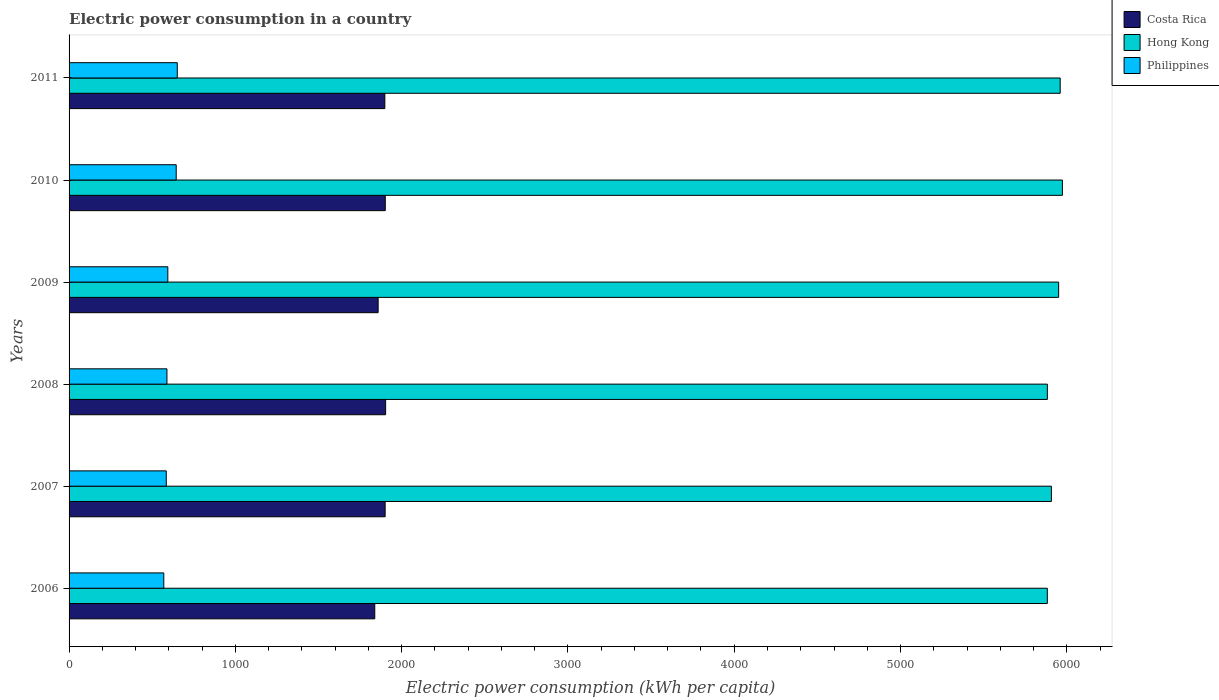How many different coloured bars are there?
Provide a short and direct response. 3. How many groups of bars are there?
Offer a terse response. 6. Are the number of bars on each tick of the Y-axis equal?
Keep it short and to the point. Yes. What is the label of the 6th group of bars from the top?
Offer a very short reply. 2006. What is the electric power consumption in in Hong Kong in 2010?
Make the answer very short. 5973.49. Across all years, what is the maximum electric power consumption in in Philippines?
Make the answer very short. 650.74. Across all years, what is the minimum electric power consumption in in Hong Kong?
Offer a terse response. 5882.81. In which year was the electric power consumption in in Philippines maximum?
Keep it short and to the point. 2011. What is the total electric power consumption in in Hong Kong in the graph?
Offer a terse response. 3.56e+04. What is the difference between the electric power consumption in in Costa Rica in 2008 and that in 2009?
Your answer should be very brief. 44.97. What is the difference between the electric power consumption in in Costa Rica in 2009 and the electric power consumption in in Hong Kong in 2011?
Your response must be concise. -4101.55. What is the average electric power consumption in in Philippines per year?
Offer a very short reply. 605.26. In the year 2006, what is the difference between the electric power consumption in in Philippines and electric power consumption in in Hong Kong?
Provide a succinct answer. -5313.15. In how many years, is the electric power consumption in in Hong Kong greater than 3000 kWh per capita?
Offer a very short reply. 6. What is the ratio of the electric power consumption in in Philippines in 2009 to that in 2010?
Give a very brief answer. 0.92. Is the electric power consumption in in Philippines in 2009 less than that in 2010?
Provide a short and direct response. Yes. What is the difference between the highest and the second highest electric power consumption in in Philippines?
Make the answer very short. 6.47. What is the difference between the highest and the lowest electric power consumption in in Hong Kong?
Ensure brevity in your answer.  90.68. In how many years, is the electric power consumption in in Hong Kong greater than the average electric power consumption in in Hong Kong taken over all years?
Your answer should be compact. 3. Is the sum of the electric power consumption in in Costa Rica in 2007 and 2010 greater than the maximum electric power consumption in in Philippines across all years?
Provide a short and direct response. Yes. What does the 2nd bar from the top in 2010 represents?
Give a very brief answer. Hong Kong. Is it the case that in every year, the sum of the electric power consumption in in Costa Rica and electric power consumption in in Hong Kong is greater than the electric power consumption in in Philippines?
Provide a succinct answer. Yes. How many bars are there?
Provide a short and direct response. 18. What is the difference between two consecutive major ticks on the X-axis?
Ensure brevity in your answer.  1000. Does the graph contain grids?
Your answer should be compact. No. Where does the legend appear in the graph?
Your response must be concise. Top right. How many legend labels are there?
Make the answer very short. 3. How are the legend labels stacked?
Provide a succinct answer. Vertical. What is the title of the graph?
Your answer should be compact. Electric power consumption in a country. What is the label or title of the X-axis?
Make the answer very short. Electric power consumption (kWh per capita). What is the label or title of the Y-axis?
Offer a very short reply. Years. What is the Electric power consumption (kWh per capita) in Costa Rica in 2006?
Your answer should be compact. 1838.34. What is the Electric power consumption (kWh per capita) in Hong Kong in 2006?
Give a very brief answer. 5882.81. What is the Electric power consumption (kWh per capita) of Philippines in 2006?
Keep it short and to the point. 569.66. What is the Electric power consumption (kWh per capita) of Costa Rica in 2007?
Keep it short and to the point. 1900.69. What is the Electric power consumption (kWh per capita) of Hong Kong in 2007?
Offer a very short reply. 5907.35. What is the Electric power consumption (kWh per capita) in Philippines in 2007?
Your answer should be compact. 584.53. What is the Electric power consumption (kWh per capita) of Costa Rica in 2008?
Make the answer very short. 1903.6. What is the Electric power consumption (kWh per capita) in Hong Kong in 2008?
Your response must be concise. 5883.04. What is the Electric power consumption (kWh per capita) in Philippines in 2008?
Give a very brief answer. 588.51. What is the Electric power consumption (kWh per capita) of Costa Rica in 2009?
Ensure brevity in your answer.  1858.63. What is the Electric power consumption (kWh per capita) in Hong Kong in 2009?
Offer a very short reply. 5950.84. What is the Electric power consumption (kWh per capita) in Philippines in 2009?
Your answer should be very brief. 593.86. What is the Electric power consumption (kWh per capita) in Costa Rica in 2010?
Keep it short and to the point. 1901.54. What is the Electric power consumption (kWh per capita) in Hong Kong in 2010?
Keep it short and to the point. 5973.49. What is the Electric power consumption (kWh per capita) in Philippines in 2010?
Give a very brief answer. 644.27. What is the Electric power consumption (kWh per capita) in Costa Rica in 2011?
Make the answer very short. 1898.93. What is the Electric power consumption (kWh per capita) of Hong Kong in 2011?
Provide a succinct answer. 5960.18. What is the Electric power consumption (kWh per capita) of Philippines in 2011?
Offer a terse response. 650.74. Across all years, what is the maximum Electric power consumption (kWh per capita) of Costa Rica?
Your answer should be very brief. 1903.6. Across all years, what is the maximum Electric power consumption (kWh per capita) in Hong Kong?
Provide a short and direct response. 5973.49. Across all years, what is the maximum Electric power consumption (kWh per capita) in Philippines?
Provide a short and direct response. 650.74. Across all years, what is the minimum Electric power consumption (kWh per capita) of Costa Rica?
Your answer should be very brief. 1838.34. Across all years, what is the minimum Electric power consumption (kWh per capita) in Hong Kong?
Offer a terse response. 5882.81. Across all years, what is the minimum Electric power consumption (kWh per capita) of Philippines?
Give a very brief answer. 569.66. What is the total Electric power consumption (kWh per capita) in Costa Rica in the graph?
Provide a short and direct response. 1.13e+04. What is the total Electric power consumption (kWh per capita) in Hong Kong in the graph?
Keep it short and to the point. 3.56e+04. What is the total Electric power consumption (kWh per capita) in Philippines in the graph?
Offer a very short reply. 3631.57. What is the difference between the Electric power consumption (kWh per capita) of Costa Rica in 2006 and that in 2007?
Provide a short and direct response. -62.36. What is the difference between the Electric power consumption (kWh per capita) of Hong Kong in 2006 and that in 2007?
Keep it short and to the point. -24.54. What is the difference between the Electric power consumption (kWh per capita) in Philippines in 2006 and that in 2007?
Provide a succinct answer. -14.87. What is the difference between the Electric power consumption (kWh per capita) in Costa Rica in 2006 and that in 2008?
Offer a very short reply. -65.26. What is the difference between the Electric power consumption (kWh per capita) in Hong Kong in 2006 and that in 2008?
Your answer should be very brief. -0.23. What is the difference between the Electric power consumption (kWh per capita) in Philippines in 2006 and that in 2008?
Offer a terse response. -18.85. What is the difference between the Electric power consumption (kWh per capita) in Costa Rica in 2006 and that in 2009?
Your answer should be very brief. -20.29. What is the difference between the Electric power consumption (kWh per capita) in Hong Kong in 2006 and that in 2009?
Ensure brevity in your answer.  -68.03. What is the difference between the Electric power consumption (kWh per capita) of Philippines in 2006 and that in 2009?
Your response must be concise. -24.2. What is the difference between the Electric power consumption (kWh per capita) of Costa Rica in 2006 and that in 2010?
Provide a succinct answer. -63.2. What is the difference between the Electric power consumption (kWh per capita) of Hong Kong in 2006 and that in 2010?
Offer a terse response. -90.68. What is the difference between the Electric power consumption (kWh per capita) of Philippines in 2006 and that in 2010?
Provide a short and direct response. -74.61. What is the difference between the Electric power consumption (kWh per capita) of Costa Rica in 2006 and that in 2011?
Ensure brevity in your answer.  -60.59. What is the difference between the Electric power consumption (kWh per capita) of Hong Kong in 2006 and that in 2011?
Provide a succinct answer. -77.37. What is the difference between the Electric power consumption (kWh per capita) of Philippines in 2006 and that in 2011?
Your answer should be compact. -81.08. What is the difference between the Electric power consumption (kWh per capita) of Costa Rica in 2007 and that in 2008?
Make the answer very short. -2.91. What is the difference between the Electric power consumption (kWh per capita) of Hong Kong in 2007 and that in 2008?
Make the answer very short. 24.31. What is the difference between the Electric power consumption (kWh per capita) in Philippines in 2007 and that in 2008?
Give a very brief answer. -3.98. What is the difference between the Electric power consumption (kWh per capita) of Costa Rica in 2007 and that in 2009?
Offer a very short reply. 42.06. What is the difference between the Electric power consumption (kWh per capita) in Hong Kong in 2007 and that in 2009?
Make the answer very short. -43.49. What is the difference between the Electric power consumption (kWh per capita) of Philippines in 2007 and that in 2009?
Offer a very short reply. -9.33. What is the difference between the Electric power consumption (kWh per capita) of Costa Rica in 2007 and that in 2010?
Your response must be concise. -0.85. What is the difference between the Electric power consumption (kWh per capita) in Hong Kong in 2007 and that in 2010?
Offer a terse response. -66.14. What is the difference between the Electric power consumption (kWh per capita) in Philippines in 2007 and that in 2010?
Offer a terse response. -59.74. What is the difference between the Electric power consumption (kWh per capita) of Costa Rica in 2007 and that in 2011?
Provide a short and direct response. 1.76. What is the difference between the Electric power consumption (kWh per capita) of Hong Kong in 2007 and that in 2011?
Your response must be concise. -52.83. What is the difference between the Electric power consumption (kWh per capita) of Philippines in 2007 and that in 2011?
Your response must be concise. -66.21. What is the difference between the Electric power consumption (kWh per capita) of Costa Rica in 2008 and that in 2009?
Give a very brief answer. 44.97. What is the difference between the Electric power consumption (kWh per capita) in Hong Kong in 2008 and that in 2009?
Make the answer very short. -67.8. What is the difference between the Electric power consumption (kWh per capita) in Philippines in 2008 and that in 2009?
Offer a terse response. -5.34. What is the difference between the Electric power consumption (kWh per capita) of Costa Rica in 2008 and that in 2010?
Your answer should be compact. 2.06. What is the difference between the Electric power consumption (kWh per capita) of Hong Kong in 2008 and that in 2010?
Keep it short and to the point. -90.45. What is the difference between the Electric power consumption (kWh per capita) in Philippines in 2008 and that in 2010?
Offer a very short reply. -55.76. What is the difference between the Electric power consumption (kWh per capita) in Costa Rica in 2008 and that in 2011?
Ensure brevity in your answer.  4.67. What is the difference between the Electric power consumption (kWh per capita) of Hong Kong in 2008 and that in 2011?
Your answer should be very brief. -77.14. What is the difference between the Electric power consumption (kWh per capita) of Philippines in 2008 and that in 2011?
Ensure brevity in your answer.  -62.23. What is the difference between the Electric power consumption (kWh per capita) in Costa Rica in 2009 and that in 2010?
Provide a succinct answer. -42.91. What is the difference between the Electric power consumption (kWh per capita) of Hong Kong in 2009 and that in 2010?
Provide a succinct answer. -22.65. What is the difference between the Electric power consumption (kWh per capita) of Philippines in 2009 and that in 2010?
Your response must be concise. -50.41. What is the difference between the Electric power consumption (kWh per capita) in Costa Rica in 2009 and that in 2011?
Keep it short and to the point. -40.3. What is the difference between the Electric power consumption (kWh per capita) of Hong Kong in 2009 and that in 2011?
Provide a short and direct response. -9.34. What is the difference between the Electric power consumption (kWh per capita) of Philippines in 2009 and that in 2011?
Provide a succinct answer. -56.89. What is the difference between the Electric power consumption (kWh per capita) in Costa Rica in 2010 and that in 2011?
Your answer should be compact. 2.61. What is the difference between the Electric power consumption (kWh per capita) in Hong Kong in 2010 and that in 2011?
Provide a succinct answer. 13.31. What is the difference between the Electric power consumption (kWh per capita) in Philippines in 2010 and that in 2011?
Offer a terse response. -6.47. What is the difference between the Electric power consumption (kWh per capita) of Costa Rica in 2006 and the Electric power consumption (kWh per capita) of Hong Kong in 2007?
Offer a very short reply. -4069.01. What is the difference between the Electric power consumption (kWh per capita) of Costa Rica in 2006 and the Electric power consumption (kWh per capita) of Philippines in 2007?
Your answer should be very brief. 1253.81. What is the difference between the Electric power consumption (kWh per capita) in Hong Kong in 2006 and the Electric power consumption (kWh per capita) in Philippines in 2007?
Your answer should be compact. 5298.28. What is the difference between the Electric power consumption (kWh per capita) in Costa Rica in 2006 and the Electric power consumption (kWh per capita) in Hong Kong in 2008?
Offer a very short reply. -4044.7. What is the difference between the Electric power consumption (kWh per capita) in Costa Rica in 2006 and the Electric power consumption (kWh per capita) in Philippines in 2008?
Make the answer very short. 1249.82. What is the difference between the Electric power consumption (kWh per capita) in Hong Kong in 2006 and the Electric power consumption (kWh per capita) in Philippines in 2008?
Your answer should be compact. 5294.29. What is the difference between the Electric power consumption (kWh per capita) of Costa Rica in 2006 and the Electric power consumption (kWh per capita) of Hong Kong in 2009?
Offer a terse response. -4112.5. What is the difference between the Electric power consumption (kWh per capita) in Costa Rica in 2006 and the Electric power consumption (kWh per capita) in Philippines in 2009?
Make the answer very short. 1244.48. What is the difference between the Electric power consumption (kWh per capita) of Hong Kong in 2006 and the Electric power consumption (kWh per capita) of Philippines in 2009?
Keep it short and to the point. 5288.95. What is the difference between the Electric power consumption (kWh per capita) of Costa Rica in 2006 and the Electric power consumption (kWh per capita) of Hong Kong in 2010?
Your answer should be compact. -4135.16. What is the difference between the Electric power consumption (kWh per capita) in Costa Rica in 2006 and the Electric power consumption (kWh per capita) in Philippines in 2010?
Your response must be concise. 1194.07. What is the difference between the Electric power consumption (kWh per capita) of Hong Kong in 2006 and the Electric power consumption (kWh per capita) of Philippines in 2010?
Offer a terse response. 5238.54. What is the difference between the Electric power consumption (kWh per capita) in Costa Rica in 2006 and the Electric power consumption (kWh per capita) in Hong Kong in 2011?
Give a very brief answer. -4121.84. What is the difference between the Electric power consumption (kWh per capita) of Costa Rica in 2006 and the Electric power consumption (kWh per capita) of Philippines in 2011?
Make the answer very short. 1187.59. What is the difference between the Electric power consumption (kWh per capita) in Hong Kong in 2006 and the Electric power consumption (kWh per capita) in Philippines in 2011?
Offer a very short reply. 5232.06. What is the difference between the Electric power consumption (kWh per capita) of Costa Rica in 2007 and the Electric power consumption (kWh per capita) of Hong Kong in 2008?
Your answer should be compact. -3982.35. What is the difference between the Electric power consumption (kWh per capita) in Costa Rica in 2007 and the Electric power consumption (kWh per capita) in Philippines in 2008?
Keep it short and to the point. 1312.18. What is the difference between the Electric power consumption (kWh per capita) in Hong Kong in 2007 and the Electric power consumption (kWh per capita) in Philippines in 2008?
Keep it short and to the point. 5318.84. What is the difference between the Electric power consumption (kWh per capita) of Costa Rica in 2007 and the Electric power consumption (kWh per capita) of Hong Kong in 2009?
Ensure brevity in your answer.  -4050.15. What is the difference between the Electric power consumption (kWh per capita) of Costa Rica in 2007 and the Electric power consumption (kWh per capita) of Philippines in 2009?
Offer a terse response. 1306.84. What is the difference between the Electric power consumption (kWh per capita) in Hong Kong in 2007 and the Electric power consumption (kWh per capita) in Philippines in 2009?
Make the answer very short. 5313.49. What is the difference between the Electric power consumption (kWh per capita) of Costa Rica in 2007 and the Electric power consumption (kWh per capita) of Hong Kong in 2010?
Your answer should be compact. -4072.8. What is the difference between the Electric power consumption (kWh per capita) in Costa Rica in 2007 and the Electric power consumption (kWh per capita) in Philippines in 2010?
Keep it short and to the point. 1256.42. What is the difference between the Electric power consumption (kWh per capita) of Hong Kong in 2007 and the Electric power consumption (kWh per capita) of Philippines in 2010?
Your answer should be compact. 5263.08. What is the difference between the Electric power consumption (kWh per capita) in Costa Rica in 2007 and the Electric power consumption (kWh per capita) in Hong Kong in 2011?
Your response must be concise. -4059.49. What is the difference between the Electric power consumption (kWh per capita) of Costa Rica in 2007 and the Electric power consumption (kWh per capita) of Philippines in 2011?
Provide a short and direct response. 1249.95. What is the difference between the Electric power consumption (kWh per capita) in Hong Kong in 2007 and the Electric power consumption (kWh per capita) in Philippines in 2011?
Provide a succinct answer. 5256.61. What is the difference between the Electric power consumption (kWh per capita) of Costa Rica in 2008 and the Electric power consumption (kWh per capita) of Hong Kong in 2009?
Provide a short and direct response. -4047.24. What is the difference between the Electric power consumption (kWh per capita) in Costa Rica in 2008 and the Electric power consumption (kWh per capita) in Philippines in 2009?
Your response must be concise. 1309.74. What is the difference between the Electric power consumption (kWh per capita) of Hong Kong in 2008 and the Electric power consumption (kWh per capita) of Philippines in 2009?
Offer a very short reply. 5289.18. What is the difference between the Electric power consumption (kWh per capita) in Costa Rica in 2008 and the Electric power consumption (kWh per capita) in Hong Kong in 2010?
Your answer should be compact. -4069.89. What is the difference between the Electric power consumption (kWh per capita) of Costa Rica in 2008 and the Electric power consumption (kWh per capita) of Philippines in 2010?
Keep it short and to the point. 1259.33. What is the difference between the Electric power consumption (kWh per capita) of Hong Kong in 2008 and the Electric power consumption (kWh per capita) of Philippines in 2010?
Ensure brevity in your answer.  5238.77. What is the difference between the Electric power consumption (kWh per capita) of Costa Rica in 2008 and the Electric power consumption (kWh per capita) of Hong Kong in 2011?
Offer a terse response. -4056.58. What is the difference between the Electric power consumption (kWh per capita) of Costa Rica in 2008 and the Electric power consumption (kWh per capita) of Philippines in 2011?
Offer a terse response. 1252.86. What is the difference between the Electric power consumption (kWh per capita) in Hong Kong in 2008 and the Electric power consumption (kWh per capita) in Philippines in 2011?
Give a very brief answer. 5232.29. What is the difference between the Electric power consumption (kWh per capita) of Costa Rica in 2009 and the Electric power consumption (kWh per capita) of Hong Kong in 2010?
Provide a succinct answer. -4114.87. What is the difference between the Electric power consumption (kWh per capita) of Costa Rica in 2009 and the Electric power consumption (kWh per capita) of Philippines in 2010?
Offer a very short reply. 1214.36. What is the difference between the Electric power consumption (kWh per capita) in Hong Kong in 2009 and the Electric power consumption (kWh per capita) in Philippines in 2010?
Keep it short and to the point. 5306.57. What is the difference between the Electric power consumption (kWh per capita) in Costa Rica in 2009 and the Electric power consumption (kWh per capita) in Hong Kong in 2011?
Keep it short and to the point. -4101.55. What is the difference between the Electric power consumption (kWh per capita) of Costa Rica in 2009 and the Electric power consumption (kWh per capita) of Philippines in 2011?
Give a very brief answer. 1207.88. What is the difference between the Electric power consumption (kWh per capita) in Hong Kong in 2009 and the Electric power consumption (kWh per capita) in Philippines in 2011?
Your answer should be very brief. 5300.09. What is the difference between the Electric power consumption (kWh per capita) of Costa Rica in 2010 and the Electric power consumption (kWh per capita) of Hong Kong in 2011?
Offer a terse response. -4058.64. What is the difference between the Electric power consumption (kWh per capita) in Costa Rica in 2010 and the Electric power consumption (kWh per capita) in Philippines in 2011?
Your answer should be compact. 1250.79. What is the difference between the Electric power consumption (kWh per capita) in Hong Kong in 2010 and the Electric power consumption (kWh per capita) in Philippines in 2011?
Keep it short and to the point. 5322.75. What is the average Electric power consumption (kWh per capita) in Costa Rica per year?
Provide a short and direct response. 1883.62. What is the average Electric power consumption (kWh per capita) of Hong Kong per year?
Give a very brief answer. 5926.28. What is the average Electric power consumption (kWh per capita) in Philippines per year?
Make the answer very short. 605.26. In the year 2006, what is the difference between the Electric power consumption (kWh per capita) of Costa Rica and Electric power consumption (kWh per capita) of Hong Kong?
Make the answer very short. -4044.47. In the year 2006, what is the difference between the Electric power consumption (kWh per capita) of Costa Rica and Electric power consumption (kWh per capita) of Philippines?
Give a very brief answer. 1268.68. In the year 2006, what is the difference between the Electric power consumption (kWh per capita) of Hong Kong and Electric power consumption (kWh per capita) of Philippines?
Provide a short and direct response. 5313.15. In the year 2007, what is the difference between the Electric power consumption (kWh per capita) in Costa Rica and Electric power consumption (kWh per capita) in Hong Kong?
Your answer should be very brief. -4006.66. In the year 2007, what is the difference between the Electric power consumption (kWh per capita) in Costa Rica and Electric power consumption (kWh per capita) in Philippines?
Your answer should be compact. 1316.16. In the year 2007, what is the difference between the Electric power consumption (kWh per capita) in Hong Kong and Electric power consumption (kWh per capita) in Philippines?
Your response must be concise. 5322.82. In the year 2008, what is the difference between the Electric power consumption (kWh per capita) of Costa Rica and Electric power consumption (kWh per capita) of Hong Kong?
Provide a short and direct response. -3979.44. In the year 2008, what is the difference between the Electric power consumption (kWh per capita) of Costa Rica and Electric power consumption (kWh per capita) of Philippines?
Your response must be concise. 1315.09. In the year 2008, what is the difference between the Electric power consumption (kWh per capita) in Hong Kong and Electric power consumption (kWh per capita) in Philippines?
Your answer should be compact. 5294.52. In the year 2009, what is the difference between the Electric power consumption (kWh per capita) in Costa Rica and Electric power consumption (kWh per capita) in Hong Kong?
Give a very brief answer. -4092.21. In the year 2009, what is the difference between the Electric power consumption (kWh per capita) of Costa Rica and Electric power consumption (kWh per capita) of Philippines?
Give a very brief answer. 1264.77. In the year 2009, what is the difference between the Electric power consumption (kWh per capita) in Hong Kong and Electric power consumption (kWh per capita) in Philippines?
Ensure brevity in your answer.  5356.98. In the year 2010, what is the difference between the Electric power consumption (kWh per capita) in Costa Rica and Electric power consumption (kWh per capita) in Hong Kong?
Your answer should be very brief. -4071.96. In the year 2010, what is the difference between the Electric power consumption (kWh per capita) in Costa Rica and Electric power consumption (kWh per capita) in Philippines?
Provide a short and direct response. 1257.27. In the year 2010, what is the difference between the Electric power consumption (kWh per capita) of Hong Kong and Electric power consumption (kWh per capita) of Philippines?
Provide a short and direct response. 5329.22. In the year 2011, what is the difference between the Electric power consumption (kWh per capita) in Costa Rica and Electric power consumption (kWh per capita) in Hong Kong?
Offer a very short reply. -4061.25. In the year 2011, what is the difference between the Electric power consumption (kWh per capita) of Costa Rica and Electric power consumption (kWh per capita) of Philippines?
Offer a very short reply. 1248.19. In the year 2011, what is the difference between the Electric power consumption (kWh per capita) in Hong Kong and Electric power consumption (kWh per capita) in Philippines?
Make the answer very short. 5309.44. What is the ratio of the Electric power consumption (kWh per capita) of Costa Rica in 2006 to that in 2007?
Your response must be concise. 0.97. What is the ratio of the Electric power consumption (kWh per capita) of Philippines in 2006 to that in 2007?
Your response must be concise. 0.97. What is the ratio of the Electric power consumption (kWh per capita) in Costa Rica in 2006 to that in 2008?
Your answer should be very brief. 0.97. What is the ratio of the Electric power consumption (kWh per capita) in Philippines in 2006 to that in 2008?
Your answer should be compact. 0.97. What is the ratio of the Electric power consumption (kWh per capita) in Costa Rica in 2006 to that in 2009?
Make the answer very short. 0.99. What is the ratio of the Electric power consumption (kWh per capita) in Philippines in 2006 to that in 2009?
Your response must be concise. 0.96. What is the ratio of the Electric power consumption (kWh per capita) in Costa Rica in 2006 to that in 2010?
Your answer should be compact. 0.97. What is the ratio of the Electric power consumption (kWh per capita) in Philippines in 2006 to that in 2010?
Keep it short and to the point. 0.88. What is the ratio of the Electric power consumption (kWh per capita) in Costa Rica in 2006 to that in 2011?
Your answer should be compact. 0.97. What is the ratio of the Electric power consumption (kWh per capita) of Hong Kong in 2006 to that in 2011?
Offer a very short reply. 0.99. What is the ratio of the Electric power consumption (kWh per capita) of Philippines in 2006 to that in 2011?
Give a very brief answer. 0.88. What is the ratio of the Electric power consumption (kWh per capita) in Costa Rica in 2007 to that in 2008?
Provide a succinct answer. 1. What is the ratio of the Electric power consumption (kWh per capita) of Hong Kong in 2007 to that in 2008?
Your answer should be compact. 1. What is the ratio of the Electric power consumption (kWh per capita) of Philippines in 2007 to that in 2008?
Your response must be concise. 0.99. What is the ratio of the Electric power consumption (kWh per capita) in Costa Rica in 2007 to that in 2009?
Provide a succinct answer. 1.02. What is the ratio of the Electric power consumption (kWh per capita) of Philippines in 2007 to that in 2009?
Your response must be concise. 0.98. What is the ratio of the Electric power consumption (kWh per capita) of Hong Kong in 2007 to that in 2010?
Ensure brevity in your answer.  0.99. What is the ratio of the Electric power consumption (kWh per capita) of Philippines in 2007 to that in 2010?
Ensure brevity in your answer.  0.91. What is the ratio of the Electric power consumption (kWh per capita) of Philippines in 2007 to that in 2011?
Ensure brevity in your answer.  0.9. What is the ratio of the Electric power consumption (kWh per capita) of Costa Rica in 2008 to that in 2009?
Your answer should be very brief. 1.02. What is the ratio of the Electric power consumption (kWh per capita) of Hong Kong in 2008 to that in 2009?
Your answer should be very brief. 0.99. What is the ratio of the Electric power consumption (kWh per capita) of Hong Kong in 2008 to that in 2010?
Offer a very short reply. 0.98. What is the ratio of the Electric power consumption (kWh per capita) of Philippines in 2008 to that in 2010?
Provide a short and direct response. 0.91. What is the ratio of the Electric power consumption (kWh per capita) in Costa Rica in 2008 to that in 2011?
Your answer should be compact. 1. What is the ratio of the Electric power consumption (kWh per capita) of Hong Kong in 2008 to that in 2011?
Ensure brevity in your answer.  0.99. What is the ratio of the Electric power consumption (kWh per capita) of Philippines in 2008 to that in 2011?
Your response must be concise. 0.9. What is the ratio of the Electric power consumption (kWh per capita) in Costa Rica in 2009 to that in 2010?
Offer a very short reply. 0.98. What is the ratio of the Electric power consumption (kWh per capita) in Philippines in 2009 to that in 2010?
Your answer should be very brief. 0.92. What is the ratio of the Electric power consumption (kWh per capita) of Costa Rica in 2009 to that in 2011?
Give a very brief answer. 0.98. What is the ratio of the Electric power consumption (kWh per capita) in Hong Kong in 2009 to that in 2011?
Your answer should be very brief. 1. What is the ratio of the Electric power consumption (kWh per capita) of Philippines in 2009 to that in 2011?
Your response must be concise. 0.91. What is the ratio of the Electric power consumption (kWh per capita) in Costa Rica in 2010 to that in 2011?
Provide a short and direct response. 1. What is the ratio of the Electric power consumption (kWh per capita) of Hong Kong in 2010 to that in 2011?
Make the answer very short. 1. What is the ratio of the Electric power consumption (kWh per capita) of Philippines in 2010 to that in 2011?
Your response must be concise. 0.99. What is the difference between the highest and the second highest Electric power consumption (kWh per capita) in Costa Rica?
Ensure brevity in your answer.  2.06. What is the difference between the highest and the second highest Electric power consumption (kWh per capita) of Hong Kong?
Make the answer very short. 13.31. What is the difference between the highest and the second highest Electric power consumption (kWh per capita) of Philippines?
Give a very brief answer. 6.47. What is the difference between the highest and the lowest Electric power consumption (kWh per capita) in Costa Rica?
Offer a terse response. 65.26. What is the difference between the highest and the lowest Electric power consumption (kWh per capita) of Hong Kong?
Provide a short and direct response. 90.68. What is the difference between the highest and the lowest Electric power consumption (kWh per capita) of Philippines?
Offer a terse response. 81.08. 